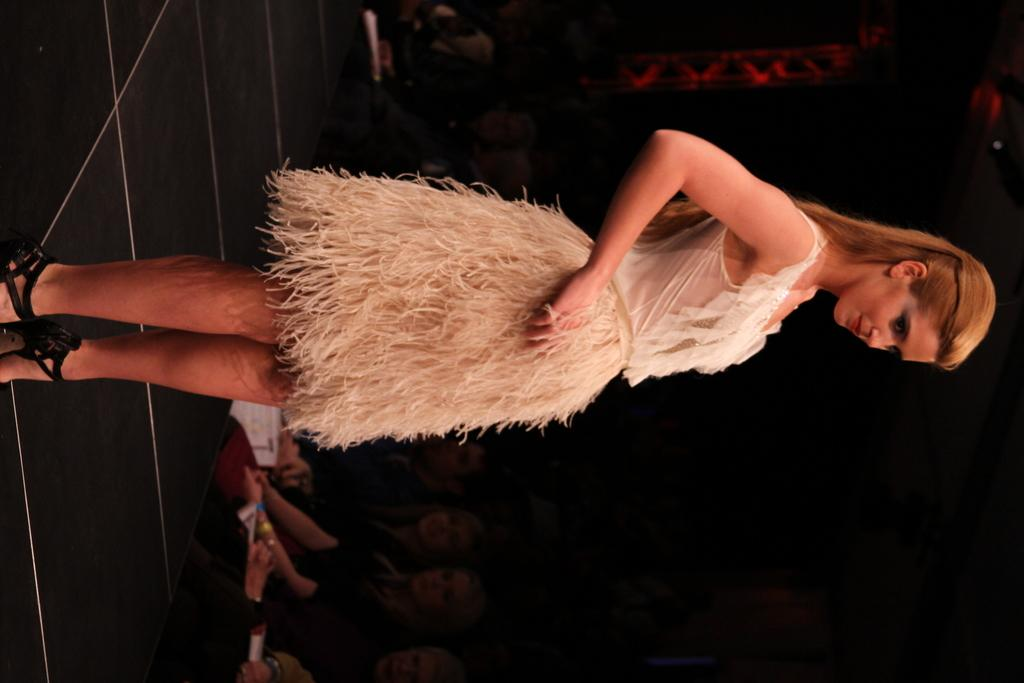What is the main subject of the image? There is a woman standing in the image. Where is the woman standing? The woman is standing on the floor. What can be seen in the background of the image? There are people and papers in the background of the image. How would you describe the lighting in the image? The background of the image is dark. What type of vegetable is the woman holding in the image? There is no vegetable present in the image; the woman is not holding anything. Can you tell me how many beggars are visible in the image? There are no beggars present in the image. 